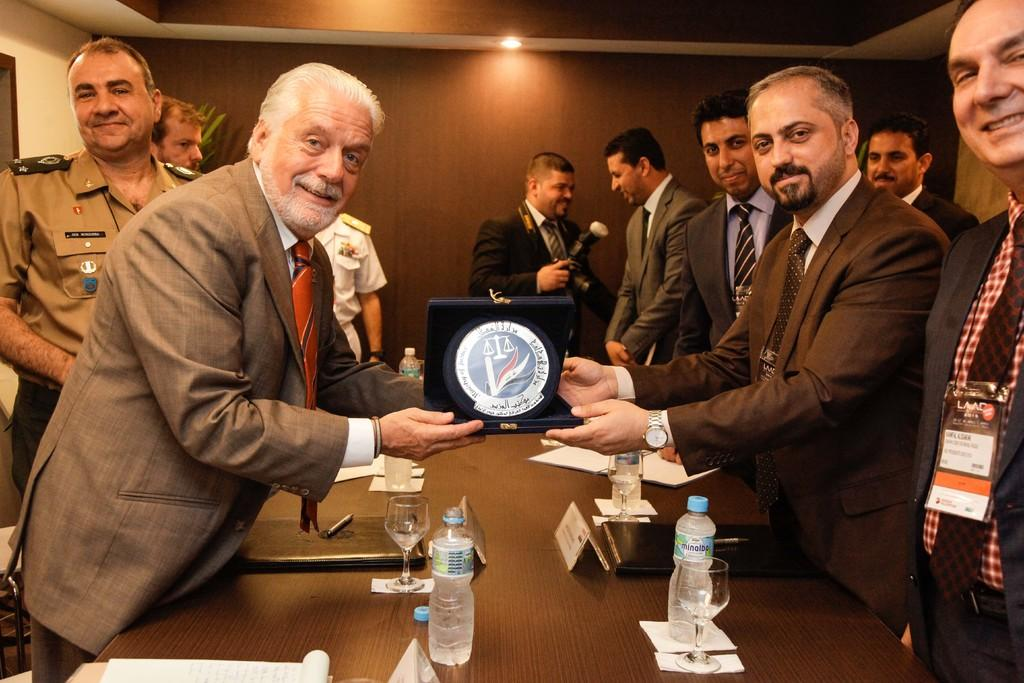What are the people in the image doing? The people in the image are standing on the floor. Is there any interaction between the people in the image? Yes, a person is giving a shield to another person. What objects can be seen on the table in the image? There are glasses and water bottles on the table. What type of camp can be seen in the background of the image? There is no camp visible in the image. Are there any servants present in the image? The image does not depict any servants. 